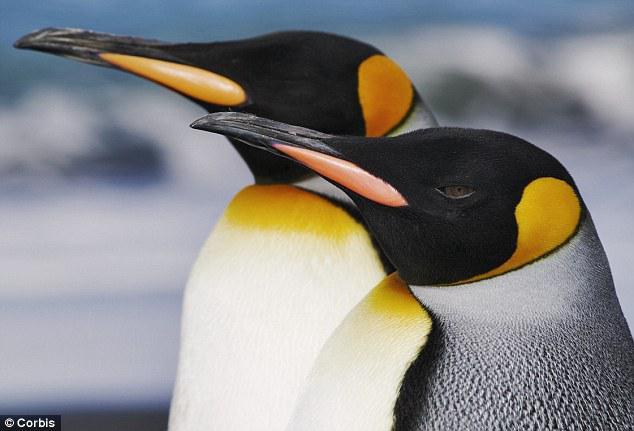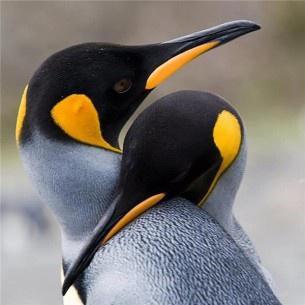The first image is the image on the left, the second image is the image on the right. Evaluate the accuracy of this statement regarding the images: "Each of the images in the pair show exactly two penguins.". Is it true? Answer yes or no. Yes. The first image is the image on the left, the second image is the image on the right. Analyze the images presented: Is the assertion "There is a total of 1 penguin grooming themselves." valid? Answer yes or no. No. 